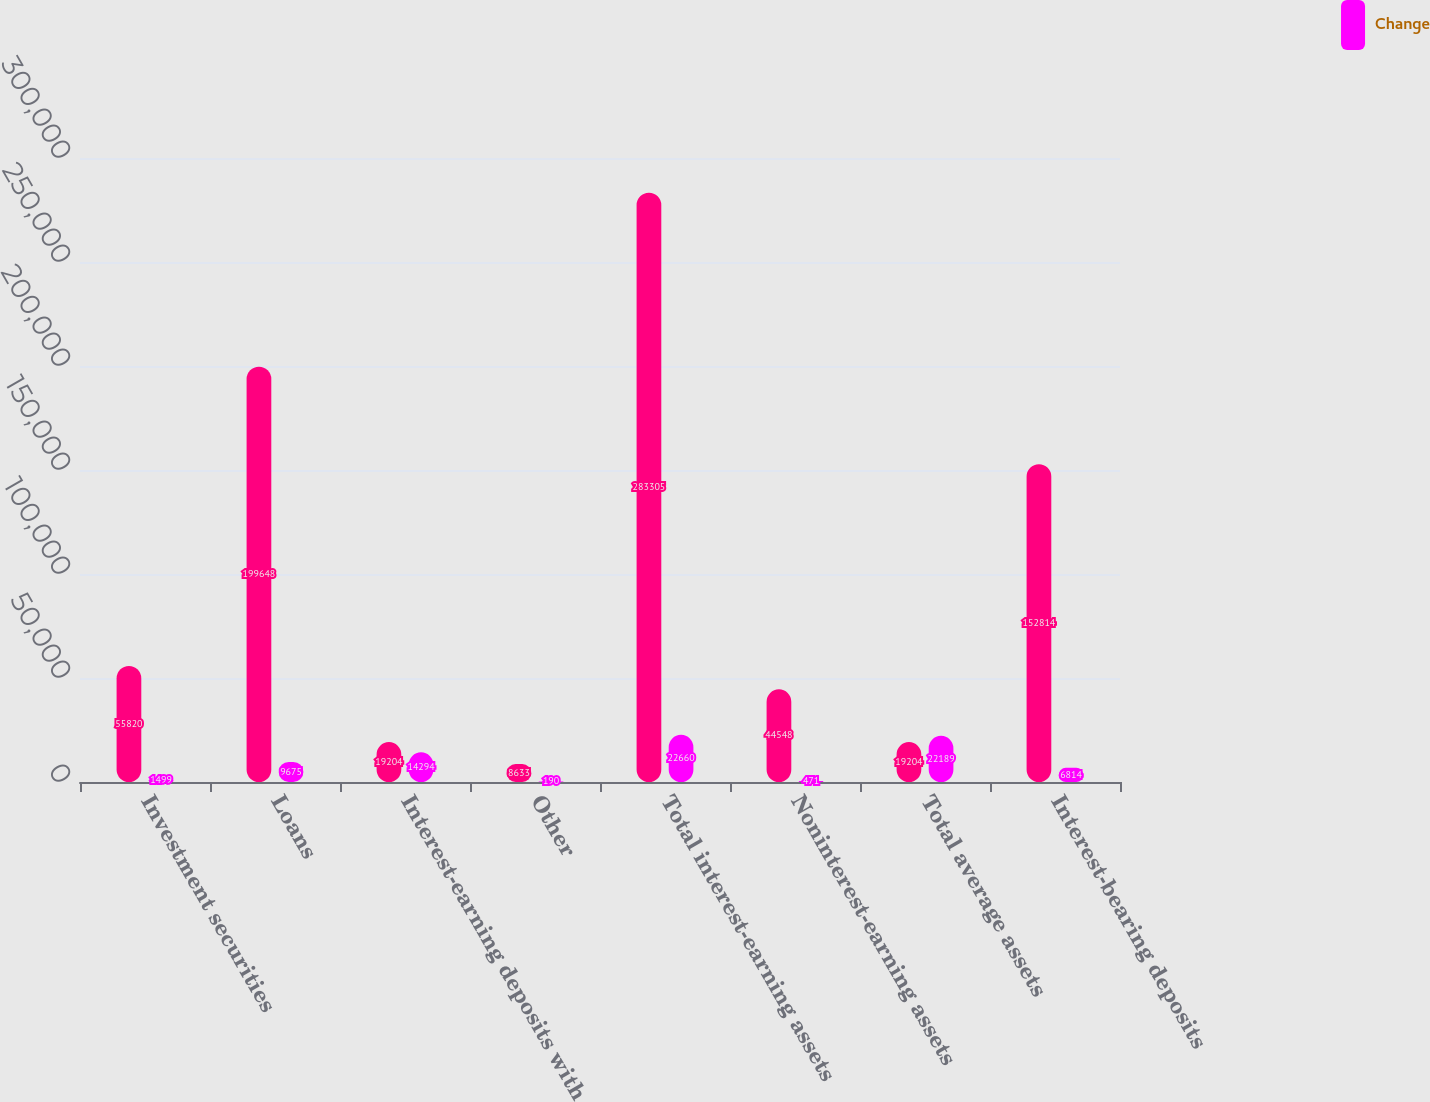<chart> <loc_0><loc_0><loc_500><loc_500><stacked_bar_chart><ecel><fcel>Investment securities<fcel>Loans<fcel>Interest-earning deposits with<fcel>Other<fcel>Total interest-earning assets<fcel>Noninterest-earning assets<fcel>Total average assets<fcel>Interest-bearing deposits<nl><fcel>nan<fcel>55820<fcel>199648<fcel>19204<fcel>8633<fcel>283305<fcel>44548<fcel>19204<fcel>152814<nl><fcel>Change<fcel>1499<fcel>9675<fcel>14294<fcel>190<fcel>22660<fcel>471<fcel>22189<fcel>6814<nl></chart> 